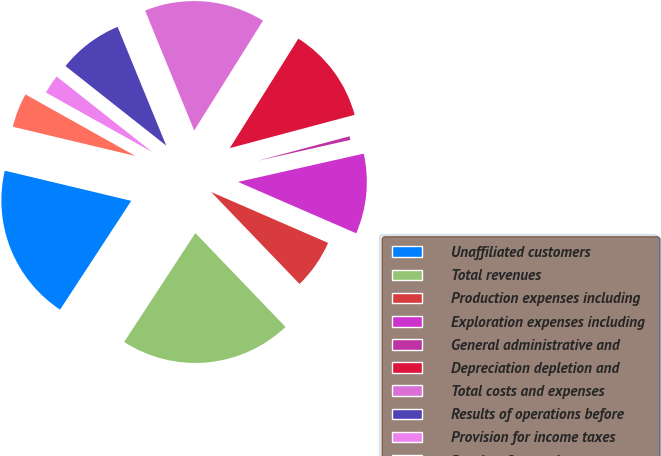Convert chart to OTSL. <chart><loc_0><loc_0><loc_500><loc_500><pie_chart><fcel>Unaffiliated customers<fcel>Total revenues<fcel>Production expenses including<fcel>Exploration expenses including<fcel>General administrative and<fcel>Depreciation depletion and<fcel>Total costs and expenses<fcel>Results of operations before<fcel>Provision for income taxes<fcel>Results of operations<nl><fcel>19.51%<fcel>21.4%<fcel>6.29%<fcel>10.06%<fcel>0.62%<fcel>11.95%<fcel>15.09%<fcel>8.18%<fcel>2.51%<fcel>4.4%<nl></chart> 